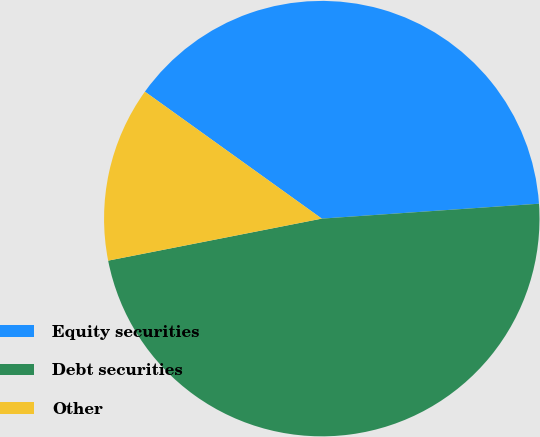Convert chart. <chart><loc_0><loc_0><loc_500><loc_500><pie_chart><fcel>Equity securities<fcel>Debt securities<fcel>Other<nl><fcel>39.0%<fcel>48.0%<fcel>13.0%<nl></chart> 